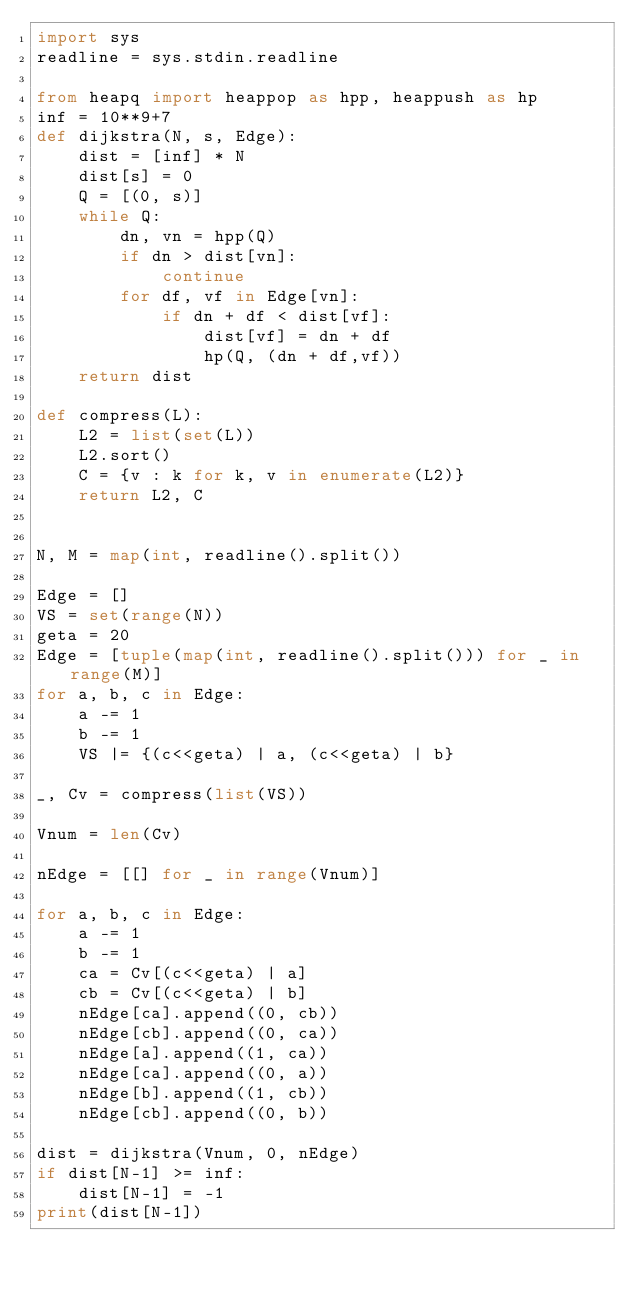<code> <loc_0><loc_0><loc_500><loc_500><_Python_>import sys
readline = sys.stdin.readline

from heapq import heappop as hpp, heappush as hp
inf = 10**9+7
def dijkstra(N, s, Edge):    
    dist = [inf] * N
    dist[s] = 0
    Q = [(0, s)]
    while Q:
        dn, vn = hpp(Q)
        if dn > dist[vn]:
            continue
        for df, vf in Edge[vn]:
            if dn + df < dist[vf]:
                dist[vf] = dn + df
                hp(Q, (dn + df,vf))
    return dist

def compress(L):
    L2 = list(set(L))
    L2.sort()
    C = {v : k for k, v in enumerate(L2)}
    return L2, C


N, M = map(int, readline().split())

Edge = []
VS = set(range(N))
geta = 20
Edge = [tuple(map(int, readline().split())) for _ in range(M)]
for a, b, c in Edge:
    a -= 1
    b -= 1
    VS |= {(c<<geta) | a, (c<<geta) | b}
   
_, Cv = compress(list(VS))

Vnum = len(Cv)

nEdge = [[] for _ in range(Vnum)]

for a, b, c in Edge:
    a -= 1
    b -= 1
    ca = Cv[(c<<geta) | a]
    cb = Cv[(c<<geta) | b]
    nEdge[ca].append((0, cb))
    nEdge[cb].append((0, ca))
    nEdge[a].append((1, ca))
    nEdge[ca].append((0, a))
    nEdge[b].append((1, cb))
    nEdge[cb].append((0, b))

dist = dijkstra(Vnum, 0, nEdge)
if dist[N-1] >= inf:
    dist[N-1] = -1
print(dist[N-1])  
</code> 